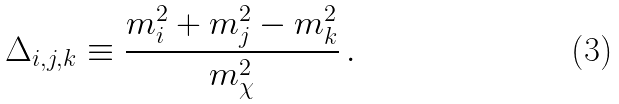<formula> <loc_0><loc_0><loc_500><loc_500>\Delta _ { i , j , k } \equiv \frac { m _ { i } ^ { 2 } + m _ { j } ^ { 2 } - m _ { k } ^ { 2 } } { m _ { \chi } ^ { 2 } } \, .</formula> 